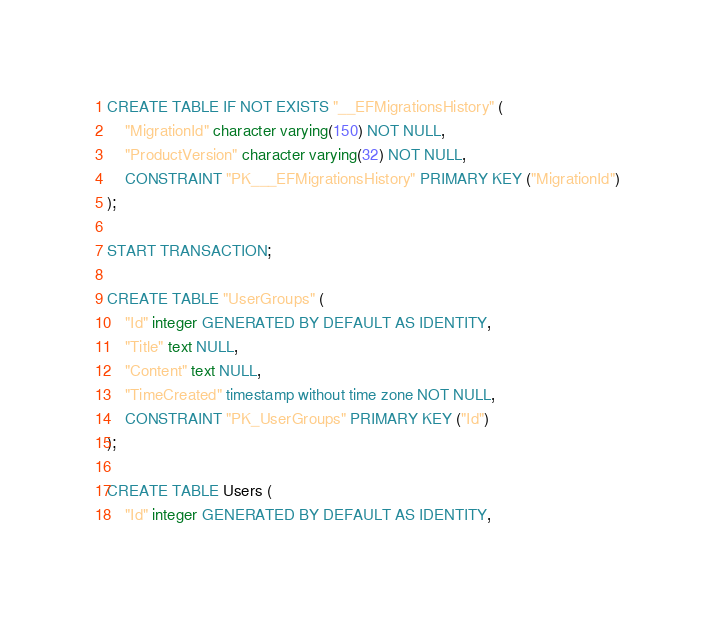Convert code to text. <code><loc_0><loc_0><loc_500><loc_500><_SQL_>CREATE TABLE IF NOT EXISTS "__EFMigrationsHistory" (
    "MigrationId" character varying(150) NOT NULL,
    "ProductVersion" character varying(32) NOT NULL,
    CONSTRAINT "PK___EFMigrationsHistory" PRIMARY KEY ("MigrationId")
);

START TRANSACTION;

CREATE TABLE "UserGroups" (
    "Id" integer GENERATED BY DEFAULT AS IDENTITY,
    "Title" text NULL,
    "Content" text NULL,
    "TimeCreated" timestamp without time zone NOT NULL,
    CONSTRAINT "PK_UserGroups" PRIMARY KEY ("Id")
);

CREATE TABLE Users (
    "Id" integer GENERATED BY DEFAULT AS IDENTITY,</code> 